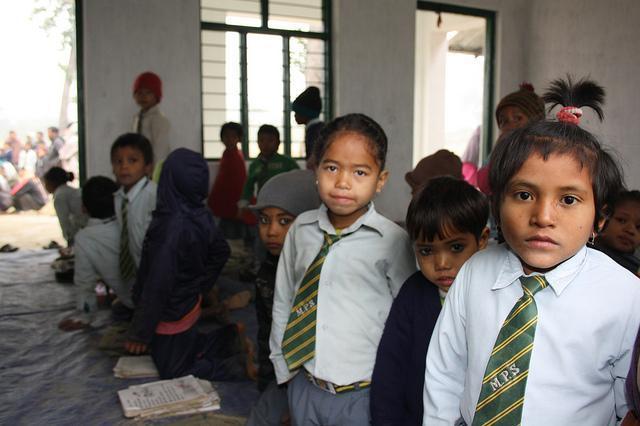How many kids wearing a tie?
Give a very brief answer. 3. How many ties are in the picture?
Give a very brief answer. 2. How many people can you see?
Give a very brief answer. 10. 